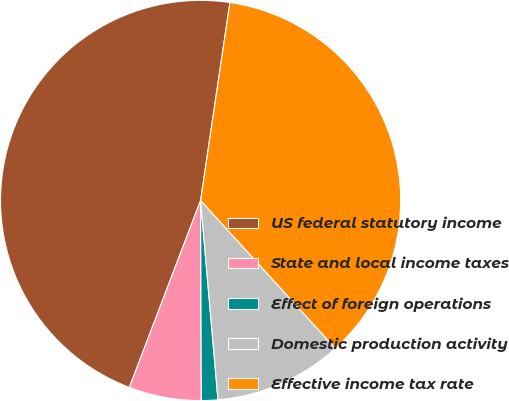Convert chart. <chart><loc_0><loc_0><loc_500><loc_500><pie_chart><fcel>US federal statutory income<fcel>State and local income taxes<fcel>Effect of foreign operations<fcel>Domestic production activity<fcel>Effective income tax rate<nl><fcel>46.54%<fcel>5.85%<fcel>1.33%<fcel>10.37%<fcel>35.9%<nl></chart> 